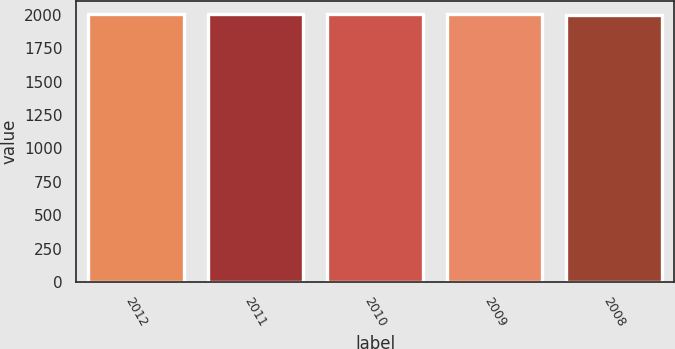<chart> <loc_0><loc_0><loc_500><loc_500><bar_chart><fcel>2012<fcel>2011<fcel>2010<fcel>2009<fcel>2008<nl><fcel>2007<fcel>2006<fcel>2005<fcel>2004<fcel>2003<nl></chart> 